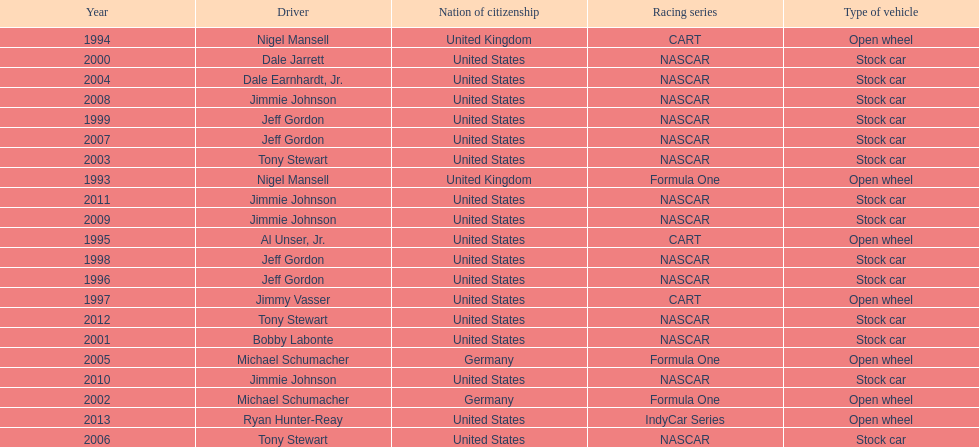Jimmy johnson won how many consecutive espy awards? 4. 